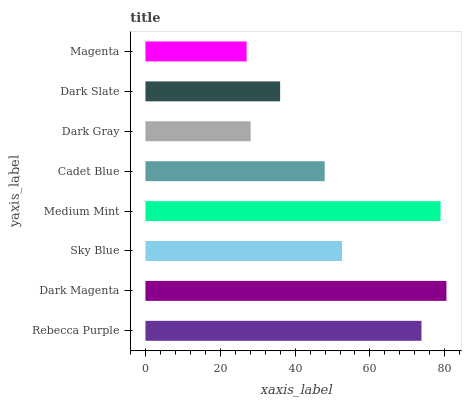Is Magenta the minimum?
Answer yes or no. Yes. Is Dark Magenta the maximum?
Answer yes or no. Yes. Is Sky Blue the minimum?
Answer yes or no. No. Is Sky Blue the maximum?
Answer yes or no. No. Is Dark Magenta greater than Sky Blue?
Answer yes or no. Yes. Is Sky Blue less than Dark Magenta?
Answer yes or no. Yes. Is Sky Blue greater than Dark Magenta?
Answer yes or no. No. Is Dark Magenta less than Sky Blue?
Answer yes or no. No. Is Sky Blue the high median?
Answer yes or no. Yes. Is Cadet Blue the low median?
Answer yes or no. Yes. Is Cadet Blue the high median?
Answer yes or no. No. Is Dark Magenta the low median?
Answer yes or no. No. 